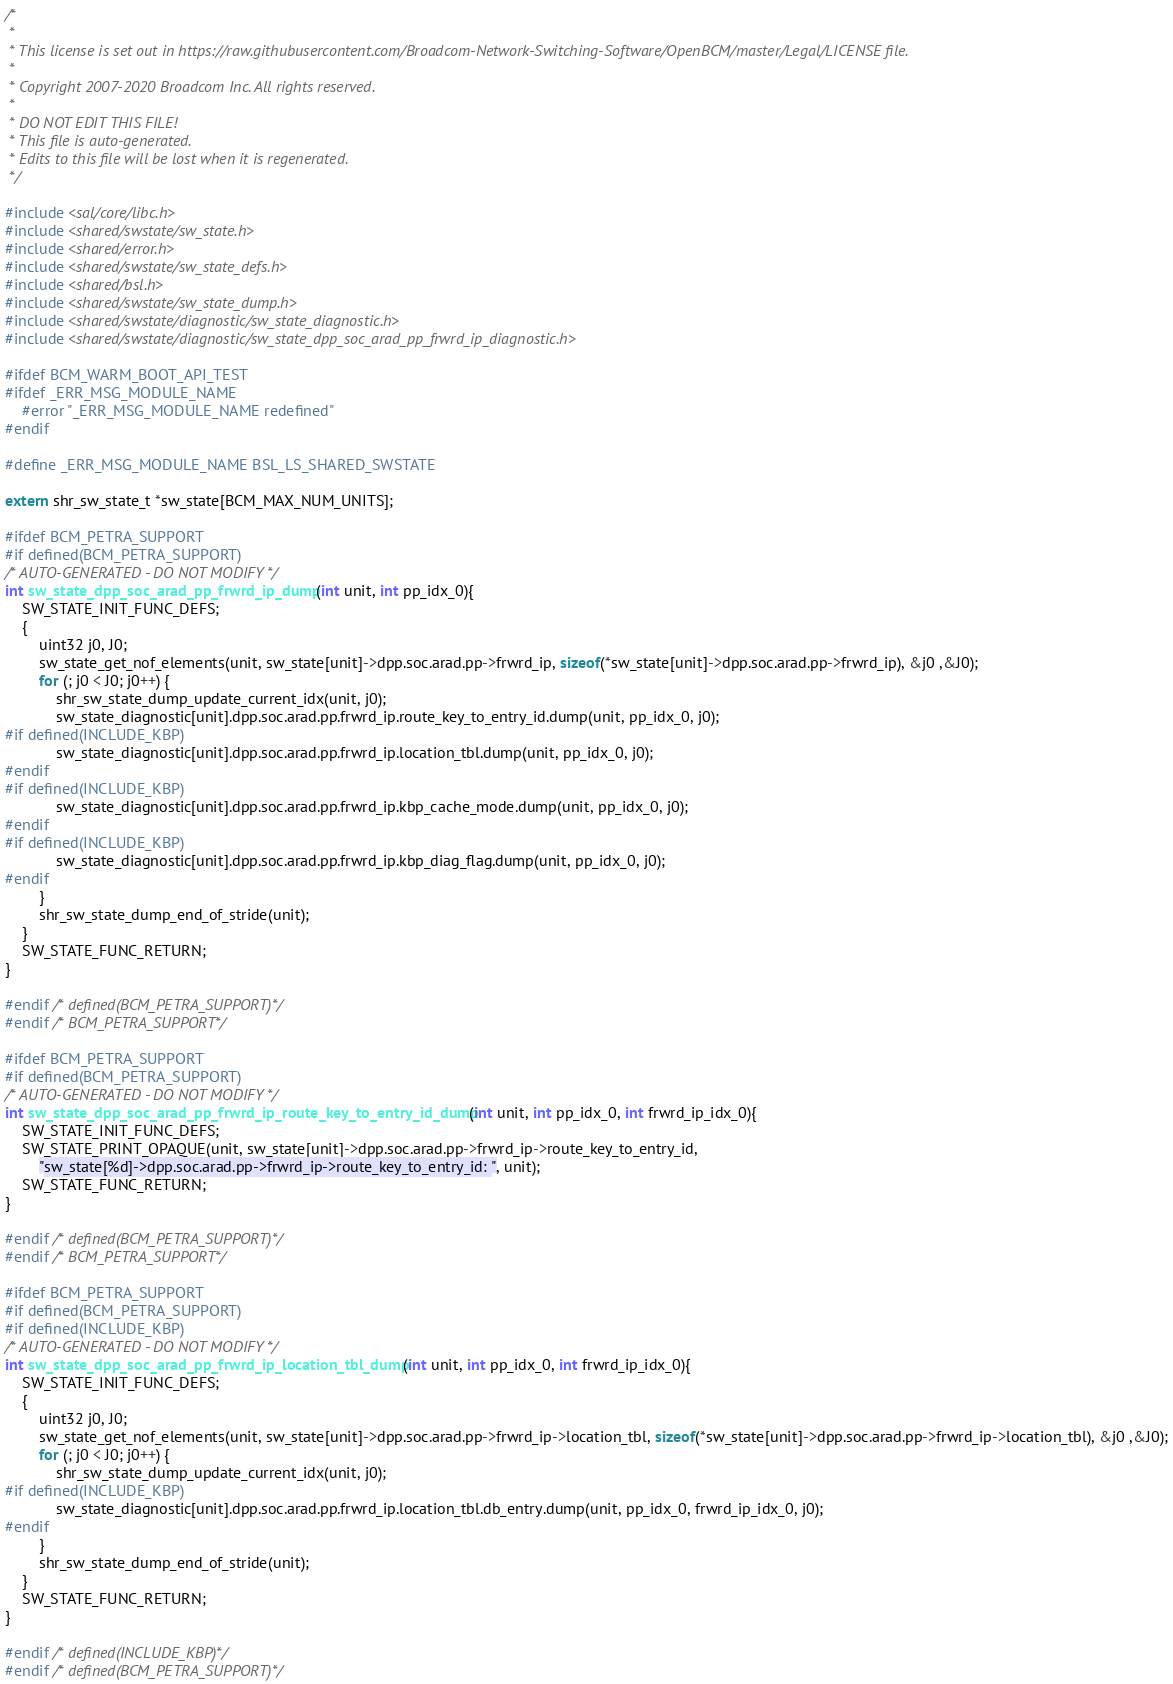Convert code to text. <code><loc_0><loc_0><loc_500><loc_500><_C_>/* 
 * 
 * This license is set out in https://raw.githubusercontent.com/Broadcom-Network-Switching-Software/OpenBCM/master/Legal/LICENSE file.
 * 
 * Copyright 2007-2020 Broadcom Inc. All rights reserved.
 * 
 * DO NOT EDIT THIS FILE!
 * This file is auto-generated.
 * Edits to this file will be lost when it is regenerated.
 */

#include <sal/core/libc.h>
#include <shared/swstate/sw_state.h>
#include <shared/error.h>
#include <shared/swstate/sw_state_defs.h>
#include <shared/bsl.h>
#include <shared/swstate/sw_state_dump.h>
#include <shared/swstate/diagnostic/sw_state_diagnostic.h>
#include <shared/swstate/diagnostic/sw_state_dpp_soc_arad_pp_frwrd_ip_diagnostic.h>

#ifdef BCM_WARM_BOOT_API_TEST
#ifdef _ERR_MSG_MODULE_NAME
    #error "_ERR_MSG_MODULE_NAME redefined"
#endif

#define _ERR_MSG_MODULE_NAME BSL_LS_SHARED_SWSTATE

extern shr_sw_state_t *sw_state[BCM_MAX_NUM_UNITS];

#ifdef BCM_PETRA_SUPPORT
#if defined(BCM_PETRA_SUPPORT)
/* AUTO-GENERATED - DO NOT MODIFY */
int sw_state_dpp_soc_arad_pp_frwrd_ip_dump(int unit, int pp_idx_0){
    SW_STATE_INIT_FUNC_DEFS;
    {
        uint32 j0, J0;
        sw_state_get_nof_elements(unit, sw_state[unit]->dpp.soc.arad.pp->frwrd_ip, sizeof(*sw_state[unit]->dpp.soc.arad.pp->frwrd_ip), &j0 ,&J0);
        for (; j0 < J0; j0++) {
            shr_sw_state_dump_update_current_idx(unit, j0);
            sw_state_diagnostic[unit].dpp.soc.arad.pp.frwrd_ip.route_key_to_entry_id.dump(unit, pp_idx_0, j0);
#if defined(INCLUDE_KBP)
            sw_state_diagnostic[unit].dpp.soc.arad.pp.frwrd_ip.location_tbl.dump(unit, pp_idx_0, j0);
#endif
#if defined(INCLUDE_KBP)
            sw_state_diagnostic[unit].dpp.soc.arad.pp.frwrd_ip.kbp_cache_mode.dump(unit, pp_idx_0, j0);
#endif
#if defined(INCLUDE_KBP)
            sw_state_diagnostic[unit].dpp.soc.arad.pp.frwrd_ip.kbp_diag_flag.dump(unit, pp_idx_0, j0);
#endif
        }
        shr_sw_state_dump_end_of_stride(unit);
    }
    SW_STATE_FUNC_RETURN;
}

#endif /* defined(BCM_PETRA_SUPPORT)*/ 
#endif /* BCM_PETRA_SUPPORT*/ 

#ifdef BCM_PETRA_SUPPORT
#if defined(BCM_PETRA_SUPPORT)
/* AUTO-GENERATED - DO NOT MODIFY */
int sw_state_dpp_soc_arad_pp_frwrd_ip_route_key_to_entry_id_dump(int unit, int pp_idx_0, int frwrd_ip_idx_0){
    SW_STATE_INIT_FUNC_DEFS;
    SW_STATE_PRINT_OPAQUE(unit, sw_state[unit]->dpp.soc.arad.pp->frwrd_ip->route_key_to_entry_id,
        "sw_state[%d]->dpp.soc.arad.pp->frwrd_ip->route_key_to_entry_id: ", unit);
    SW_STATE_FUNC_RETURN;
}

#endif /* defined(BCM_PETRA_SUPPORT)*/ 
#endif /* BCM_PETRA_SUPPORT*/ 

#ifdef BCM_PETRA_SUPPORT
#if defined(BCM_PETRA_SUPPORT)
#if defined(INCLUDE_KBP)
/* AUTO-GENERATED - DO NOT MODIFY */
int sw_state_dpp_soc_arad_pp_frwrd_ip_location_tbl_dump(int unit, int pp_idx_0, int frwrd_ip_idx_0){
    SW_STATE_INIT_FUNC_DEFS;
    {
        uint32 j0, J0;
        sw_state_get_nof_elements(unit, sw_state[unit]->dpp.soc.arad.pp->frwrd_ip->location_tbl, sizeof(*sw_state[unit]->dpp.soc.arad.pp->frwrd_ip->location_tbl), &j0 ,&J0);
        for (; j0 < J0; j0++) {
            shr_sw_state_dump_update_current_idx(unit, j0);
#if defined(INCLUDE_KBP)
            sw_state_diagnostic[unit].dpp.soc.arad.pp.frwrd_ip.location_tbl.db_entry.dump(unit, pp_idx_0, frwrd_ip_idx_0, j0);
#endif
        }
        shr_sw_state_dump_end_of_stride(unit);
    }
    SW_STATE_FUNC_RETURN;
}

#endif /* defined(INCLUDE_KBP)*/ 
#endif /* defined(BCM_PETRA_SUPPORT)*/ </code> 